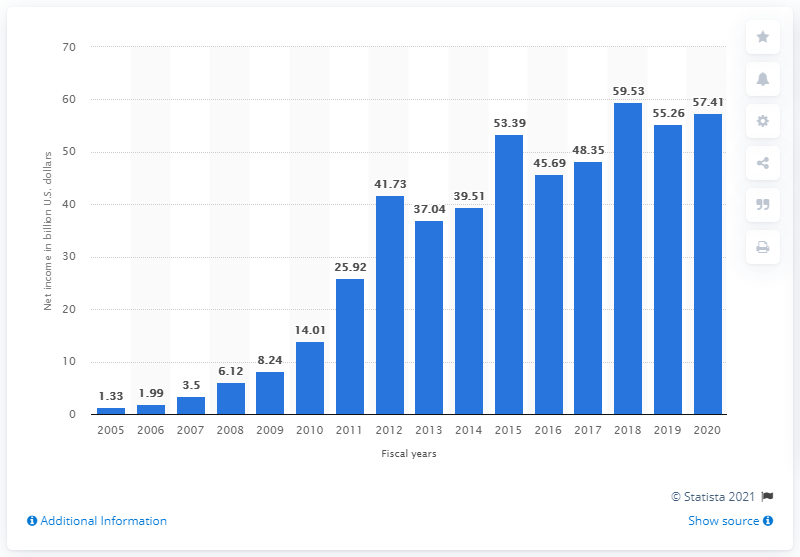Outline some significant characteristics in this image. The net income of Apple in the 2020 fiscal year was 57.41. 